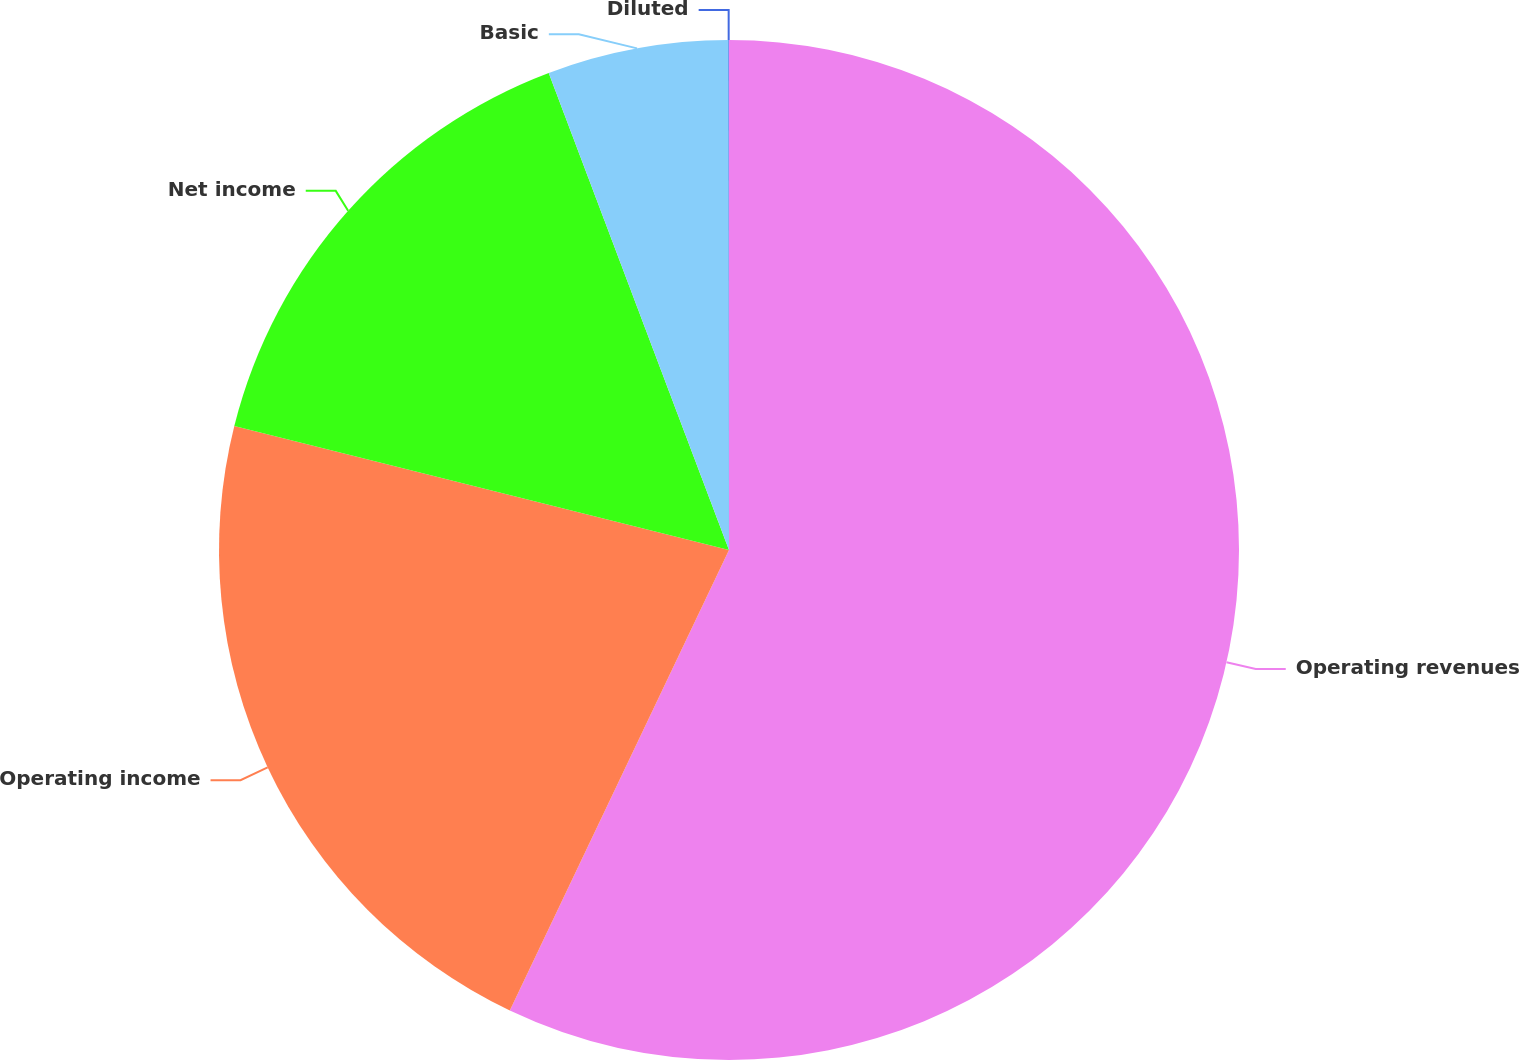<chart> <loc_0><loc_0><loc_500><loc_500><pie_chart><fcel>Operating revenues<fcel>Operating income<fcel>Net income<fcel>Basic<fcel>Diluted<nl><fcel>57.07%<fcel>21.84%<fcel>15.34%<fcel>5.73%<fcel>0.02%<nl></chart> 